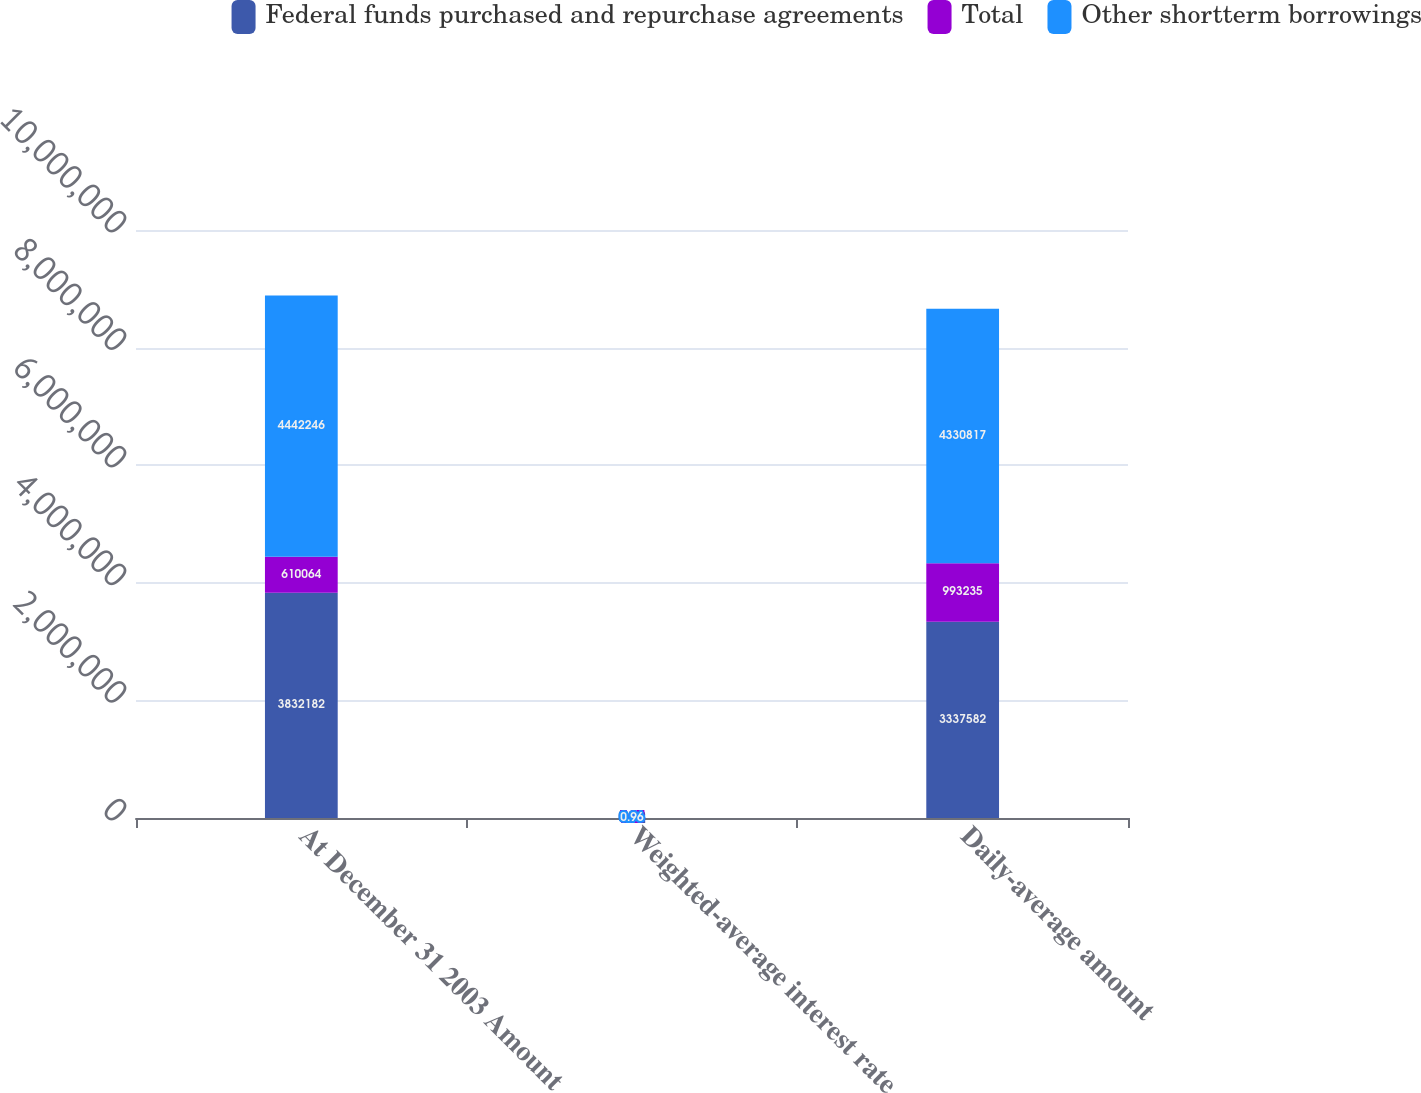Convert chart to OTSL. <chart><loc_0><loc_0><loc_500><loc_500><stacked_bar_chart><ecel><fcel>At December 31 2003 Amount<fcel>Weighted-average interest rate<fcel>Daily-average amount<nl><fcel>Federal funds purchased and repurchase agreements<fcel>3.83218e+06<fcel>0.92<fcel>3.33758e+06<nl><fcel>Total<fcel>610064<fcel>1.25<fcel>993235<nl><fcel>Other shortterm borrowings<fcel>4.44225e+06<fcel>0.96<fcel>4.33082e+06<nl></chart> 